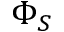Convert formula to latex. <formula><loc_0><loc_0><loc_500><loc_500>\Phi _ { S }</formula> 